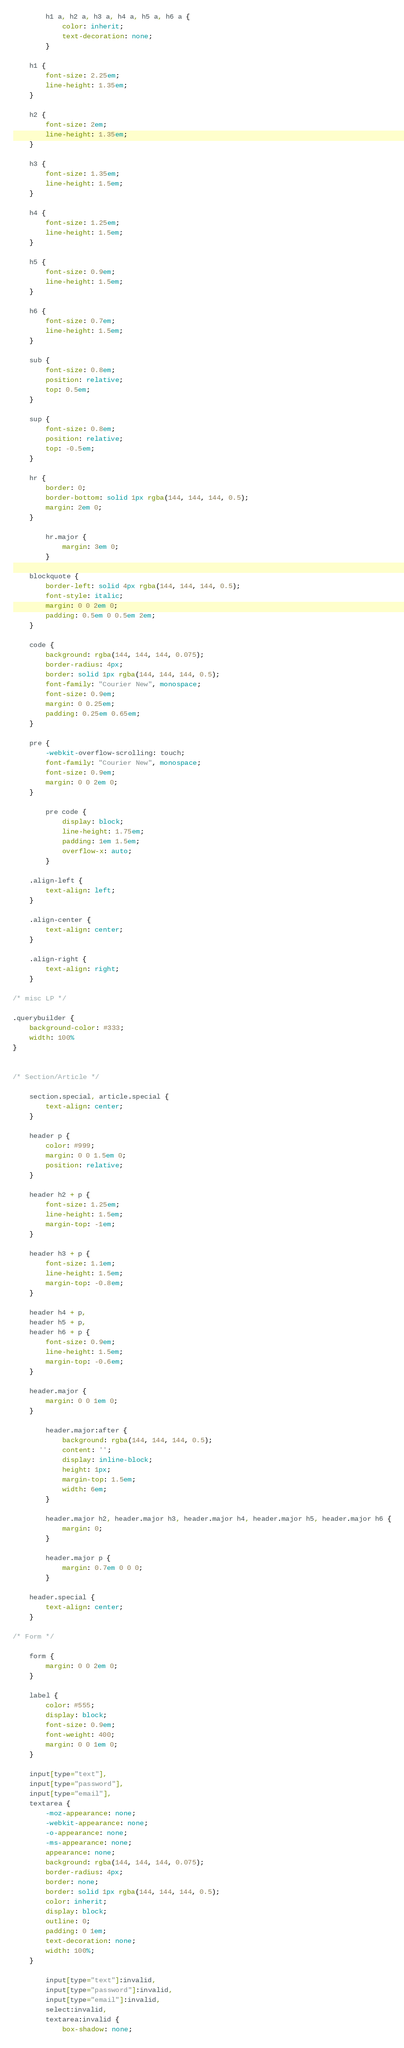<code> <loc_0><loc_0><loc_500><loc_500><_CSS_>		h1 a, h2 a, h3 a, h4 a, h5 a, h6 a {
			color: inherit;
			text-decoration: none;
		}

	h1 {
		font-size: 2.25em;
		line-height: 1.35em;
	}

	h2 {
		font-size: 2em;
		line-height: 1.35em;
	}

	h3 {
		font-size: 1.35em;
		line-height: 1.5em;
	}

	h4 {
		font-size: 1.25em;
		line-height: 1.5em;
	}

	h5 {
		font-size: 0.9em;
		line-height: 1.5em;
	}

	h6 {
		font-size: 0.7em;
		line-height: 1.5em;
	}

	sub {
		font-size: 0.8em;
		position: relative;
		top: 0.5em;
	}

	sup {
		font-size: 0.8em;
		position: relative;
		top: -0.5em;
	}

	hr {
		border: 0;
		border-bottom: solid 1px rgba(144, 144, 144, 0.5);
		margin: 2em 0;
	}

		hr.major {
			margin: 3em 0;
		}

	blockquote {
		border-left: solid 4px rgba(144, 144, 144, 0.5);
		font-style: italic;
		margin: 0 0 2em 0;
		padding: 0.5em 0 0.5em 2em;
	}

	code {
		background: rgba(144, 144, 144, 0.075);
		border-radius: 4px;
		border: solid 1px rgba(144, 144, 144, 0.5);
		font-family: "Courier New", monospace;
		font-size: 0.9em;
		margin: 0 0.25em;
		padding: 0.25em 0.65em;
	}

	pre {
		-webkit-overflow-scrolling: touch;
		font-family: "Courier New", monospace;
		font-size: 0.9em;
		margin: 0 0 2em 0;
	}

		pre code {
			display: block;
			line-height: 1.75em;
			padding: 1em 1.5em;
			overflow-x: auto;
		}

	.align-left {
		text-align: left;
	}

	.align-center {
		text-align: center;
	}

	.align-right {
		text-align: right;
	}

/* misc LP */

.querybuilder {
	background-color: #333;
	width: 100%
}


/* Section/Article */

	section.special, article.special {
		text-align: center;
	}

	header p {
		color: #999;
		margin: 0 0 1.5em 0;
		position: relative;
	}

	header h2 + p {
		font-size: 1.25em;
		line-height: 1.5em;
		margin-top: -1em;
	}

	header h3 + p {
		font-size: 1.1em;
		line-height: 1.5em;
		margin-top: -0.8em;
	}

	header h4 + p,
	header h5 + p,
	header h6 + p {
		font-size: 0.9em;
		line-height: 1.5em;
		margin-top: -0.6em;
	}

	header.major {
		margin: 0 0 1em 0;
	}

		header.major:after {
			background: rgba(144, 144, 144, 0.5);
			content: '';
			display: inline-block;
			height: 1px;
			margin-top: 1.5em;
			width: 6em;
		}

		header.major h2, header.major h3, header.major h4, header.major h5, header.major h6 {
			margin: 0;
		}

		header.major p {
			margin: 0.7em 0 0 0;
		}

	header.special {
		text-align: center;
	}

/* Form */

	form {
		margin: 0 0 2em 0;
	}

	label {
		color: #555;
		display: block;
		font-size: 0.9em;
		font-weight: 400;
		margin: 0 0 1em 0;
	}

	input[type="text"],
	input[type="password"],
	input[type="email"],
	textarea {
		-moz-appearance: none;
		-webkit-appearance: none;
		-o-appearance: none;
		-ms-appearance: none;
		appearance: none;
		background: rgba(144, 144, 144, 0.075);
		border-radius: 4px;
		border: none;
		border: solid 1px rgba(144, 144, 144, 0.5);
		color: inherit;
		display: block;
		outline: 0;
		padding: 0 1em;
		text-decoration: none;
		width: 100%;
	}

		input[type="text"]:invalid,
		input[type="password"]:invalid,
		input[type="email"]:invalid,
		select:invalid,
		textarea:invalid {
			box-shadow: none;</code> 